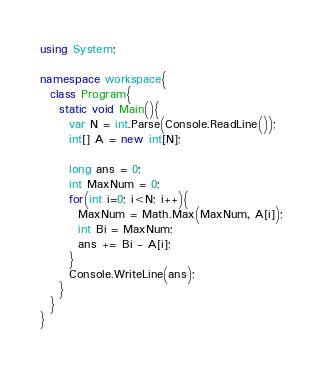<code> <loc_0><loc_0><loc_500><loc_500><_C#_>using System;
 
namespace workspace{
  class Program{
    static void Main(){
      var N = int.Parse(Console.ReadLine());
      int[] A = new int[N]; 

      long ans = 0;
      int MaxNum = 0;
      for(int i=0; i<N; i++){
        MaxNum = Math.Max(MaxNum, A[i]);
        int Bi = MaxNum;
        ans += Bi - A[i];
      }
      Console.WriteLine(ans);
    }
  }
}
</code> 